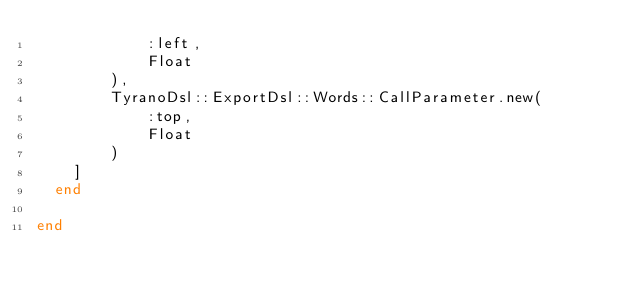Convert code to text. <code><loc_0><loc_0><loc_500><loc_500><_Ruby_>            :left,
            Float
        ),
        TyranoDsl::ExportDsl::Words::CallParameter.new(
            :top,
            Float
        )
    ]
  end

end</code> 